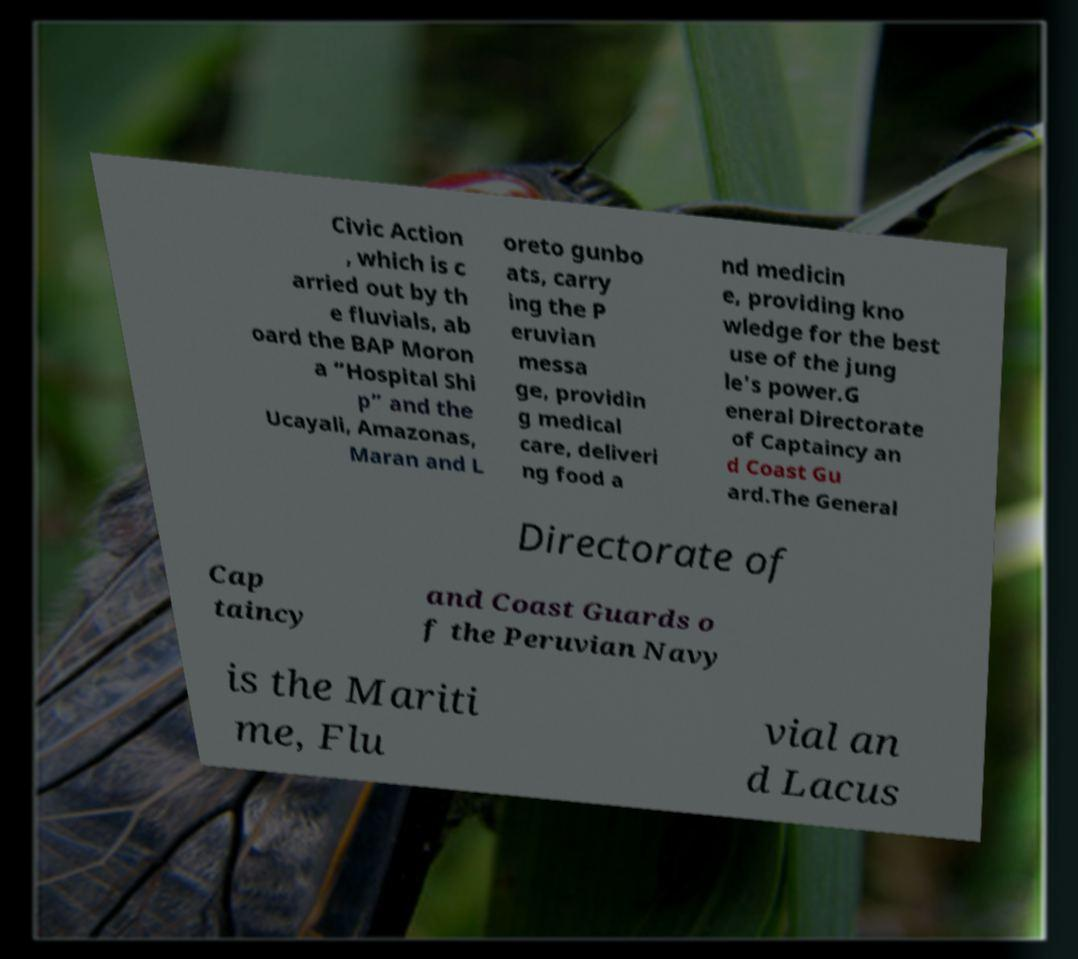There's text embedded in this image that I need extracted. Can you transcribe it verbatim? Civic Action , which is c arried out by th e fluvials, ab oard the BAP Moron a “Hospital Shi p” and the Ucayali, Amazonas, Maran and L oreto gunbo ats, carry ing the P eruvian messa ge, providin g medical care, deliveri ng food a nd medicin e, providing kno wledge for the best use of the jung le's power.G eneral Directorate of Captaincy an d Coast Gu ard.The General Directorate of Cap taincy and Coast Guards o f the Peruvian Navy is the Mariti me, Flu vial an d Lacus 